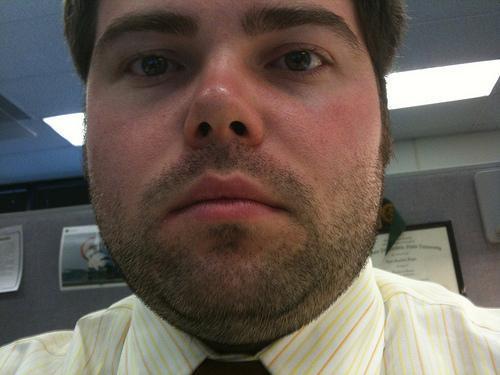How many people are in this picture?
Give a very brief answer. 1. How many different colored stripes are there on his shirt?
Give a very brief answer. 2. How many things can we see on the wall behind him?
Give a very brief answer. 4. 